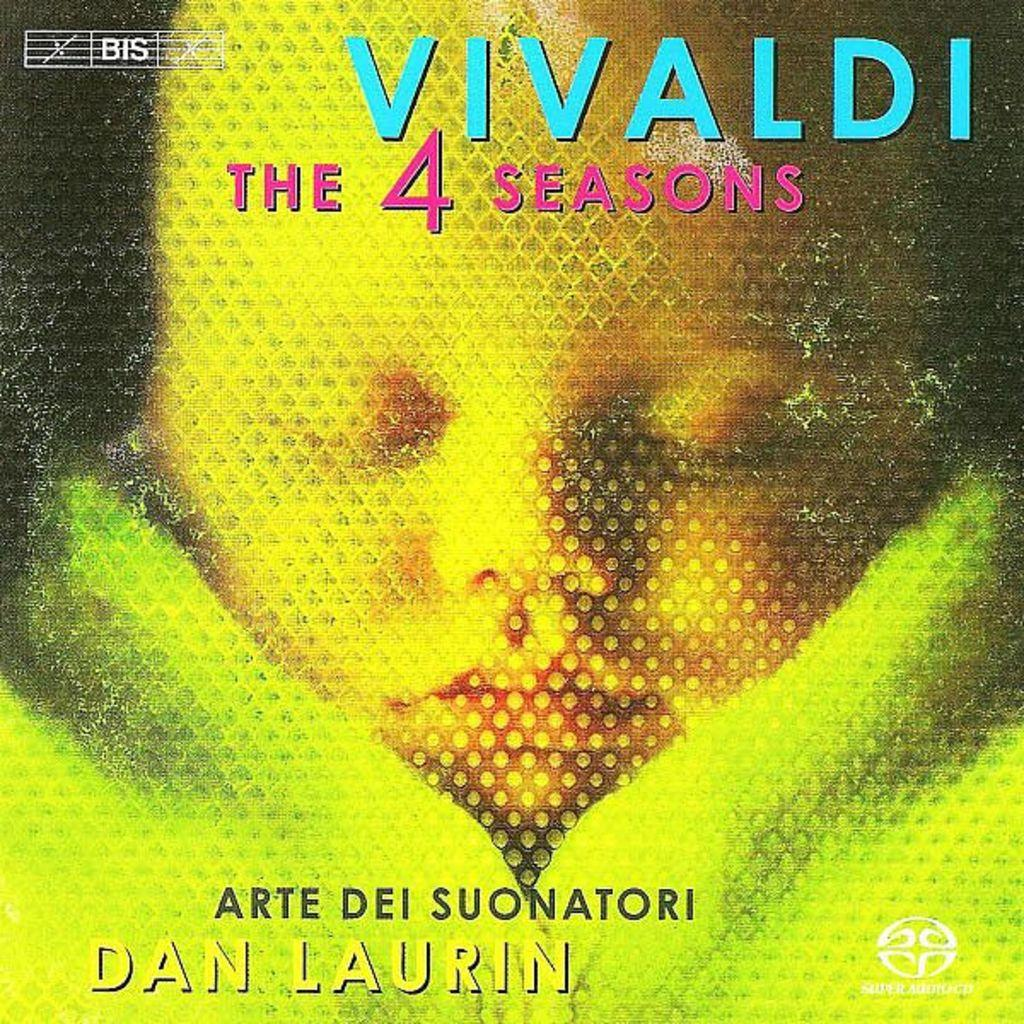<image>
Relay a brief, clear account of the picture shown. A CD case for Vivaldi's The 4 Seasons. 